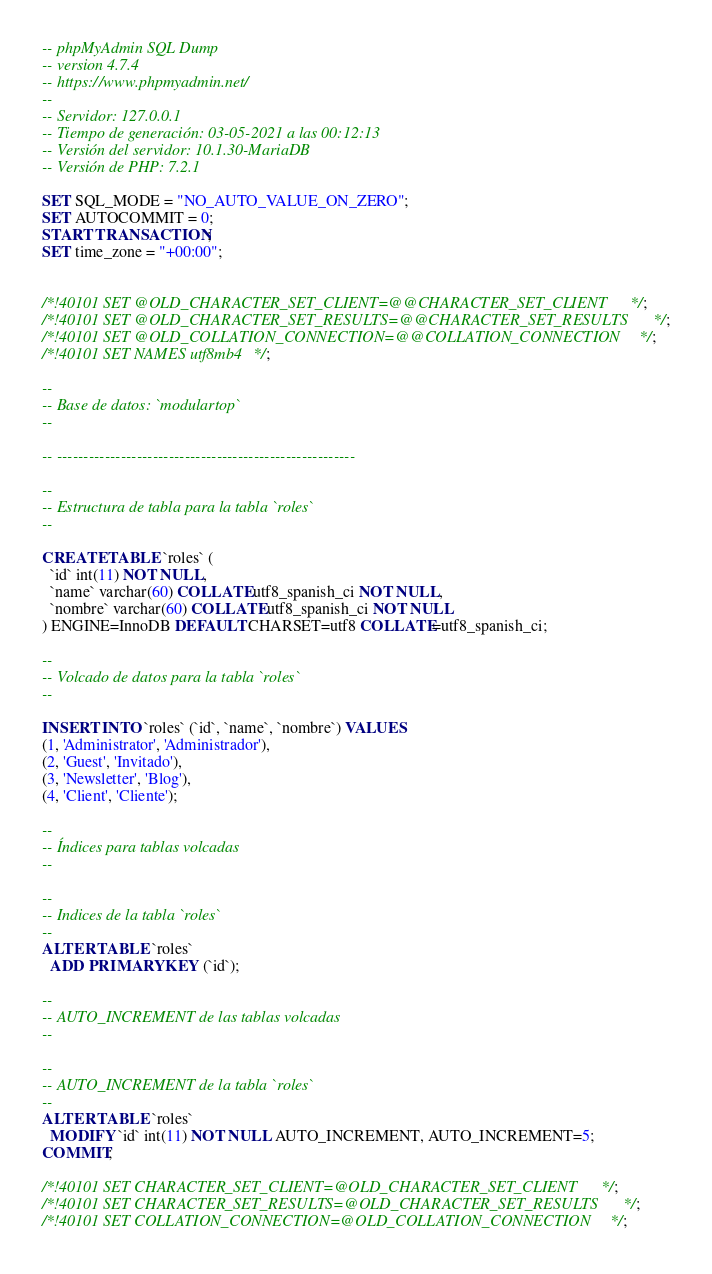<code> <loc_0><loc_0><loc_500><loc_500><_SQL_>-- phpMyAdmin SQL Dump
-- version 4.7.4
-- https://www.phpmyadmin.net/
--
-- Servidor: 127.0.0.1
-- Tiempo de generación: 03-05-2021 a las 00:12:13
-- Versión del servidor: 10.1.30-MariaDB
-- Versión de PHP: 7.2.1

SET SQL_MODE = "NO_AUTO_VALUE_ON_ZERO";
SET AUTOCOMMIT = 0;
START TRANSACTION;
SET time_zone = "+00:00";


/*!40101 SET @OLD_CHARACTER_SET_CLIENT=@@CHARACTER_SET_CLIENT */;
/*!40101 SET @OLD_CHARACTER_SET_RESULTS=@@CHARACTER_SET_RESULTS */;
/*!40101 SET @OLD_COLLATION_CONNECTION=@@COLLATION_CONNECTION */;
/*!40101 SET NAMES utf8mb4 */;

--
-- Base de datos: `modulartop`
--

-- --------------------------------------------------------

--
-- Estructura de tabla para la tabla `roles`
--

CREATE TABLE `roles` (
  `id` int(11) NOT NULL,
  `name` varchar(60) COLLATE utf8_spanish_ci NOT NULL,
  `nombre` varchar(60) COLLATE utf8_spanish_ci NOT NULL
) ENGINE=InnoDB DEFAULT CHARSET=utf8 COLLATE=utf8_spanish_ci;

--
-- Volcado de datos para la tabla `roles`
--

INSERT INTO `roles` (`id`, `name`, `nombre`) VALUES
(1, 'Administrator', 'Administrador'),
(2, 'Guest', 'Invitado'),
(3, 'Newsletter', 'Blog'),
(4, 'Client', 'Cliente');

--
-- Índices para tablas volcadas
--

--
-- Indices de la tabla `roles`
--
ALTER TABLE `roles`
  ADD PRIMARY KEY (`id`);

--
-- AUTO_INCREMENT de las tablas volcadas
--

--
-- AUTO_INCREMENT de la tabla `roles`
--
ALTER TABLE `roles`
  MODIFY `id` int(11) NOT NULL AUTO_INCREMENT, AUTO_INCREMENT=5;
COMMIT;

/*!40101 SET CHARACTER_SET_CLIENT=@OLD_CHARACTER_SET_CLIENT */;
/*!40101 SET CHARACTER_SET_RESULTS=@OLD_CHARACTER_SET_RESULTS */;
/*!40101 SET COLLATION_CONNECTION=@OLD_COLLATION_CONNECTION */;
</code> 